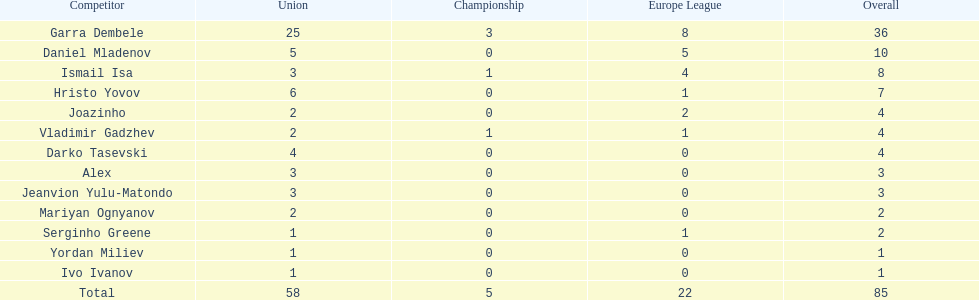Which player is in the same league as joazinho and vladimir gadzhev? Mariyan Ognyanov. Could you parse the entire table? {'header': ['Competitor', 'Union', 'Championship', 'Europe League', 'Overall'], 'rows': [['Garra Dembele', '25', '3', '8', '36'], ['Daniel Mladenov', '5', '0', '5', '10'], ['Ismail Isa', '3', '1', '4', '8'], ['Hristo Yovov', '6', '0', '1', '7'], ['Joazinho', '2', '0', '2', '4'], ['Vladimir Gadzhev', '2', '1', '1', '4'], ['Darko Tasevski', '4', '0', '0', '4'], ['Alex', '3', '0', '0', '3'], ['Jeanvion Yulu-Matondo', '3', '0', '0', '3'], ['Mariyan Ognyanov', '2', '0', '0', '2'], ['Serginho Greene', '1', '0', '1', '2'], ['Yordan Miliev', '1', '0', '0', '1'], ['Ivo Ivanov', '1', '0', '0', '1'], ['Total', '58', '5', '22', '85']]} 